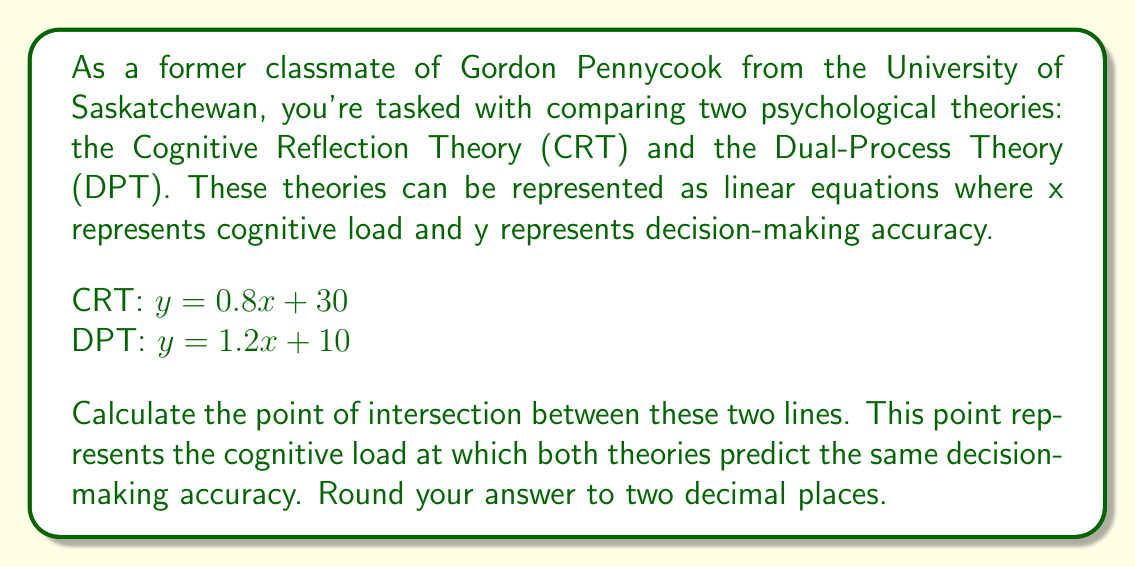Help me with this question. To find the point of intersection between two lines, we need to solve the system of equations:

$$\begin{cases}
y = 0.8x + 30 \\
y = 1.2x + 10
\end{cases}$$

Step 1: Set the equations equal to each other
$0.8x + 30 = 1.2x + 10$

Step 2: Subtract 0.8x from both sides
$30 = 0.4x + 10$

Step 3: Subtract 10 from both sides
$20 = 0.4x$

Step 4: Divide both sides by 0.4
$x = 20 / 0.4 = 50$

Step 5: Substitute x = 50 into either of the original equations to find y
Using CRT: $y = 0.8(50) + 30 = 40 + 30 = 70$

Therefore, the point of intersection is (50, 70).

The x-coordinate (50) represents the cognitive load, and the y-coordinate (70) represents the decision-making accuracy at the intersection point.
Answer: The point of intersection is (50.00, 70.00). 